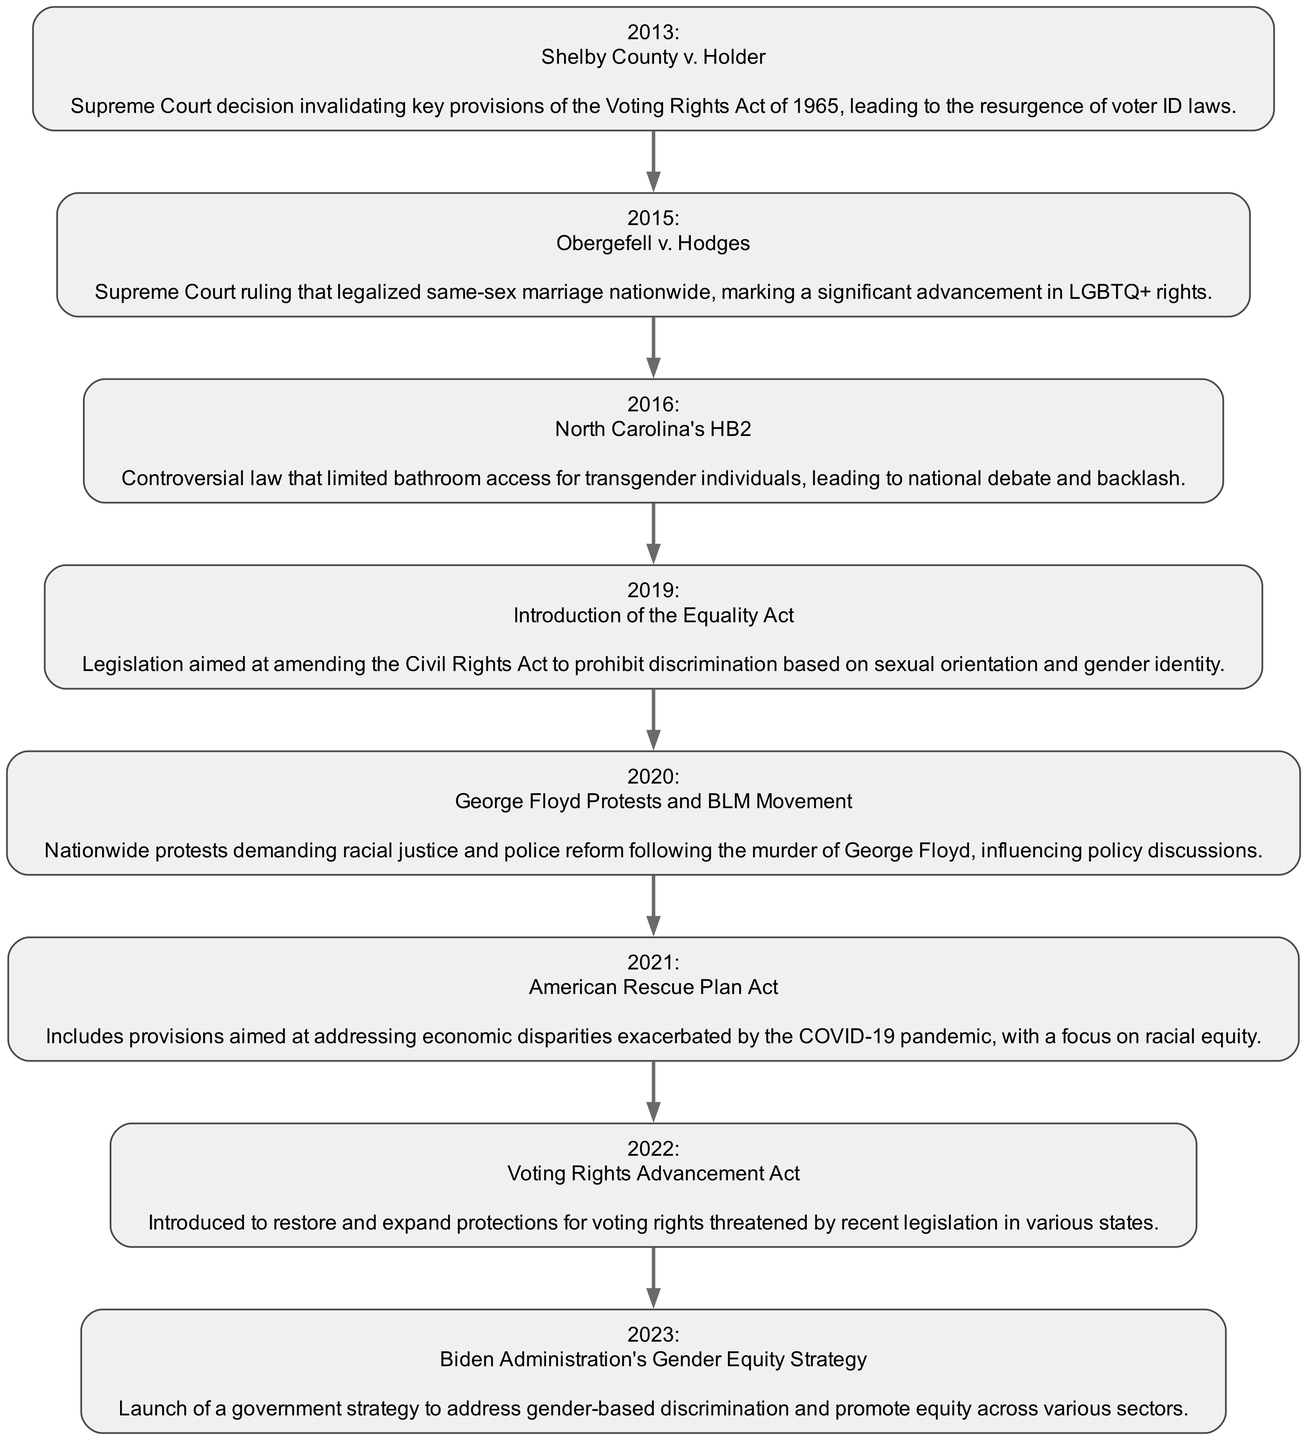What year did the Supreme Court rule on Obergefell v. Hodges? The diagram indicates that the event of Obergefell v. Hodges took place in 2015, as it is clearly marked with that year in the flow chart.
Answer: 2015 What significant advancement in rights is associated with the event of Obergefell v. Hodges? The diagram describes Obergefell v. Hodges as the event that legalized same-sex marriage nationwide, marking a key advancement in LGBTQ+ rights.
Answer: LGBTQ+ rights How many events are listed in the timeline? By counting the number of entries in the timeline section of the diagram, we see there are a total of eight significant legislative changes affecting civil rights noted.
Answer: 8 Which event addresses provisions for racial equity relating to the COVID-19 pandemic? The diagram shows that the American Rescue Plan Act in 2021 includes provisions aimed at addressing economic disparities, especially those exacerbated by the COVID-19 pandemic.
Answer: American Rescue Plan Act What was the main issue raised by North Carolina's HB2 in 2016? According to the diagram, North Carolina's HB2 was a controversial law that specifically limited bathroom access for transgender individuals, sparking national debate and backlash.
Answer: Bathroom access for transgender individuals Which event marks the beginning of nationwide protests for racial justice in 2020? The diagram indicates that the George Floyd protests and the Black Lives Matter movement began in 2020 in response to the murder of George Floyd, which led to demands for racial justice and police reform.
Answer: George Floyd Protests and BLM Movement What legislative act was introduced in 2019 to prohibit discrimination based on sexual orientation? The timeline mentions the introduction of the Equality Act in 2019, which aimed to amend the Civil Rights Act to include prohibitions against discrimination based on sexual orientation and gender identity.
Answer: Equality Act What event is associated with the Biden Administration's Gender Equity Strategy? The diagram illustrates that in 2023, the Biden Administration launched a Gender Equity Strategy, which aims to address gender-based discrimination across various sectors.
Answer: Biden Administration's Gender Equity Strategy Which event in the timeline occurred immediately before the introduction of the Voting Rights Advancement Act? By examining the diagram's flow, we see that the event immediately preceding the Voting Rights Advancement Act is the American Rescue Plan Act from 2021.
Answer: American Rescue Plan Act 